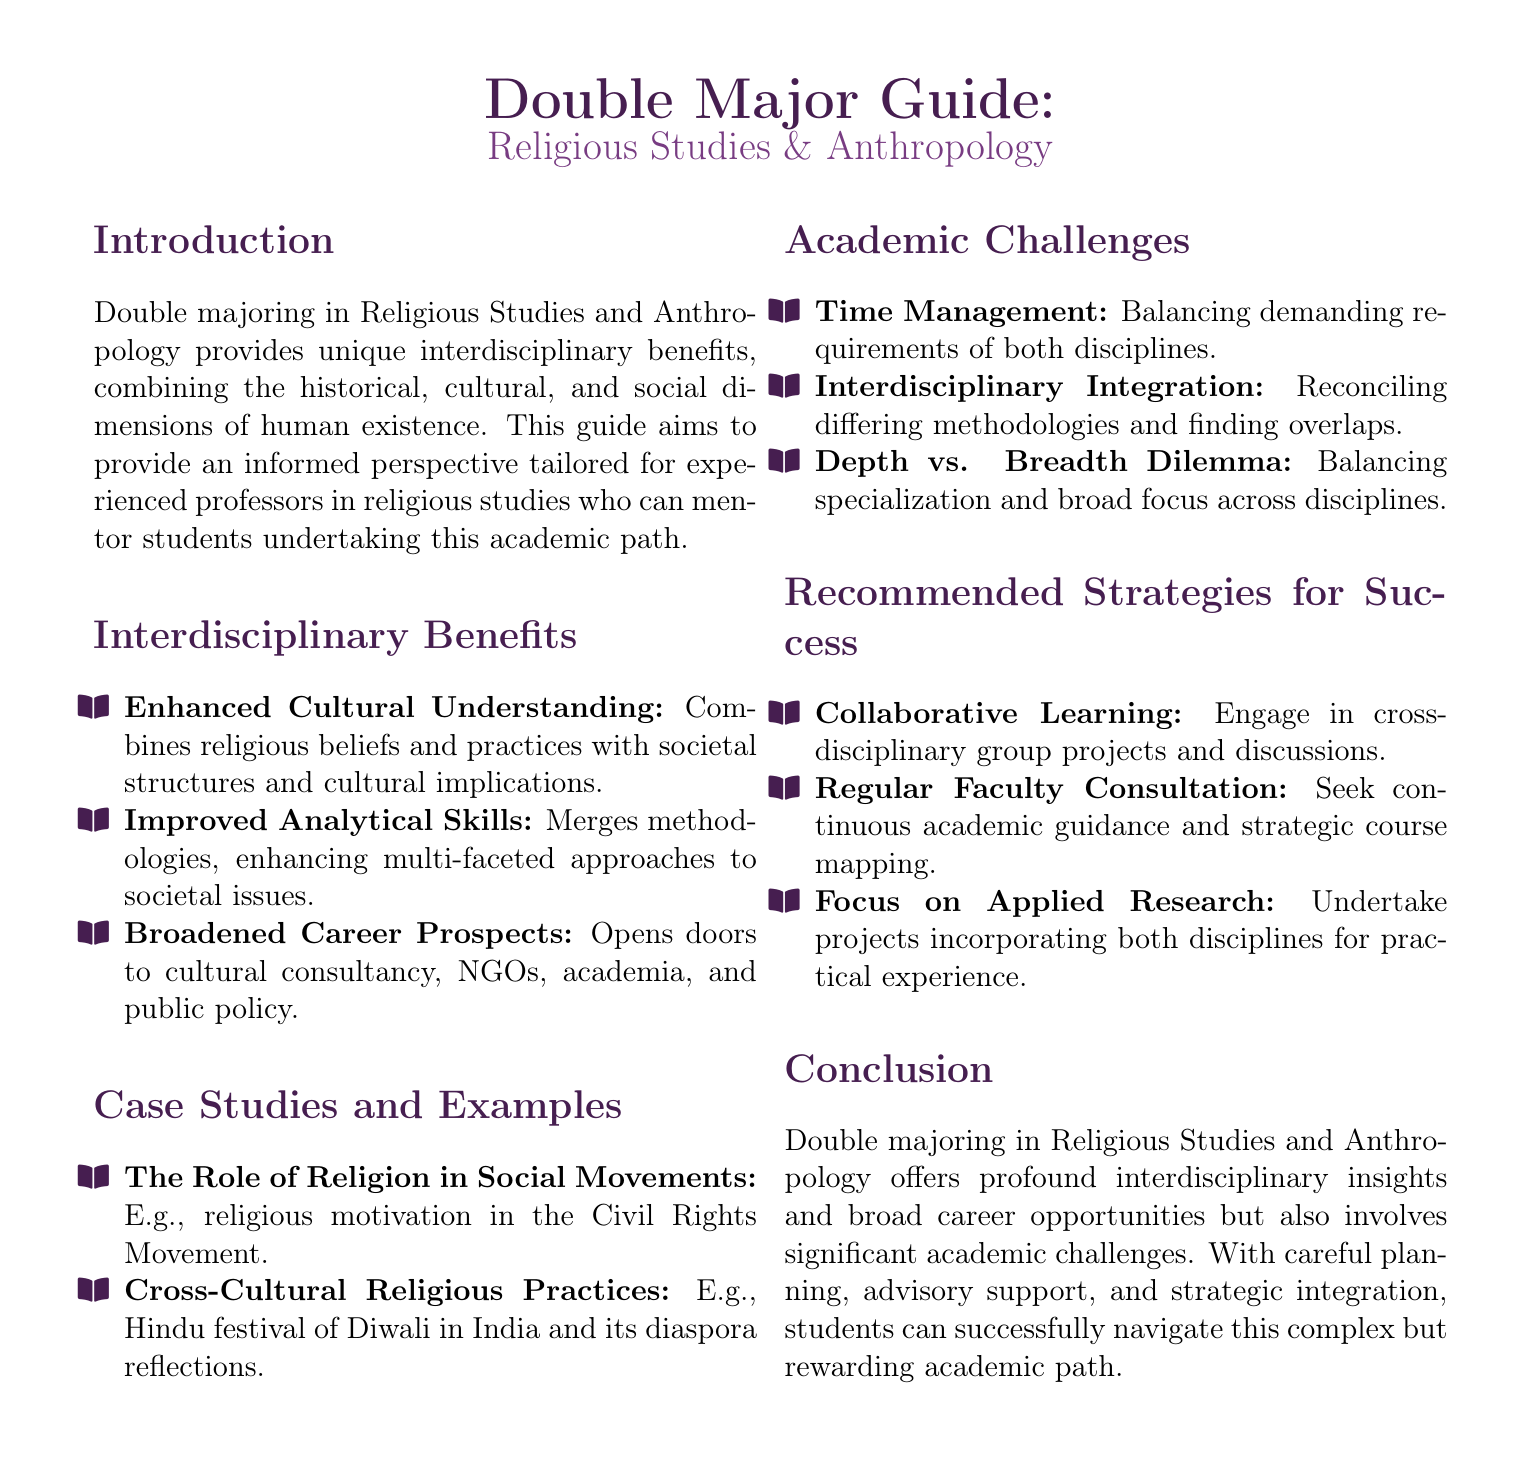What are the two disciplines involved in the double major? The document identifies the two disciplines as Religious Studies and Anthropology.
Answer: Religious Studies and Anthropology What is one benefit of double majoring mentioned in the document? The document lists several benefits, including enhanced cultural understanding, improved analytical skills, and broadened career prospects. One of these is enhanced cultural understanding.
Answer: Enhanced Cultural Understanding What is one example given in the case studies section? The document provides examples such as the role of religion in social movements and cross-cultural religious practices. One example is the role of religion in social movements.
Answer: The Role of Religion in Social Movements What is a major challenge cited for students double majoring? The document mentions challenges such as time management, interdisciplinary integration, and the depth vs. breadth dilemma. Time management is one of the cited challenges.
Answer: Time Management What is a recommended strategy for success according to the guide? The guide offers strategies such as collaborative learning, regular faculty consultation, and focusing on applied research. Collaborative learning is one of the recommended strategies.
Answer: Collaborative Learning 